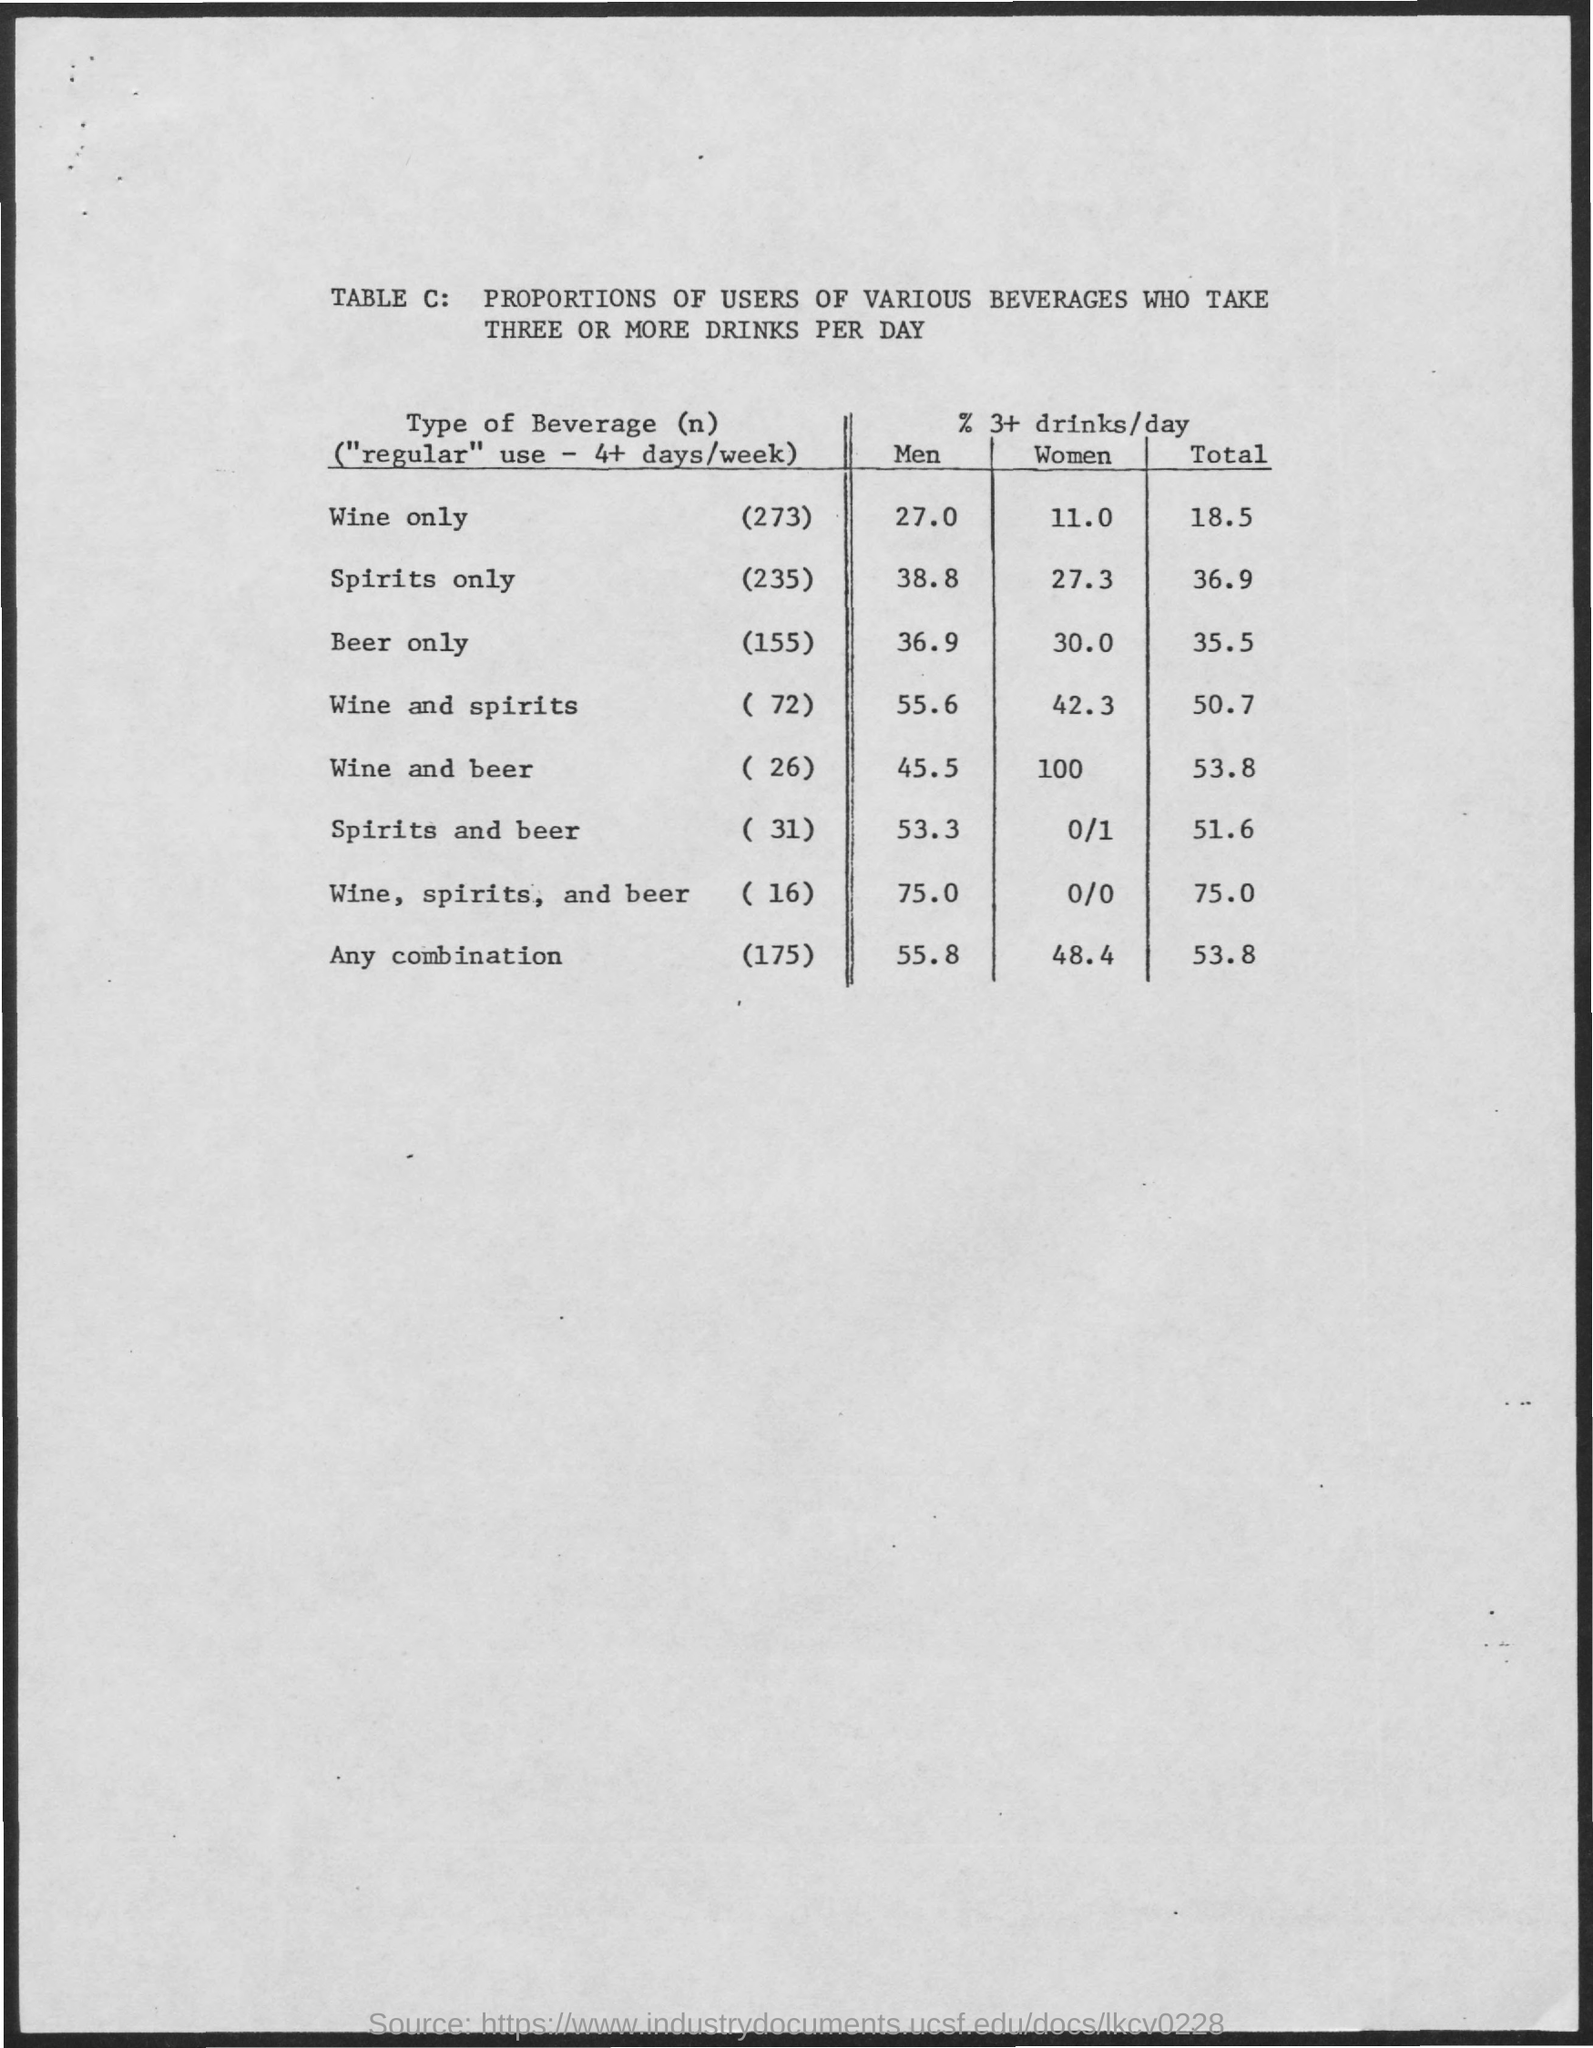What is the % 0f 3+ drinks/day of Men who drink Wine only?
Provide a short and direct response. 27.0. What is the % 0f 3+ drinks/day of Men who drink Spirits only?
Your answer should be compact. 38.8. What is the % 0f 3+ drinks/day of Men who drink Beer only?
Offer a terse response. 36 9. What is the % 0f 3+ drinks/day of Men who drink Wine and spirits?
Give a very brief answer. 55.6. What is the % 0f 3+ drinks/day of Men who drink Spirits and Beer?
Ensure brevity in your answer.  53.3. What is the % 0f 3+ drinks/day of Men who drink Wine, spirits and beer?
Offer a very short reply. 75. What is the % 0f 3+ drinks/day of WoMen who drink Wine only?
Offer a terse response. 11.0. What is the % 0f 3+ drinks/day of WoMen who drink Spirits only?
Provide a succinct answer. 27.3. What is the % 0f 3+ drinks/day of WoMen who drink Beer only?
Ensure brevity in your answer.  30. What is the % 0f 3+ drinks/day of WoMen who drink Wine and Beer?
Your response must be concise. 100. 